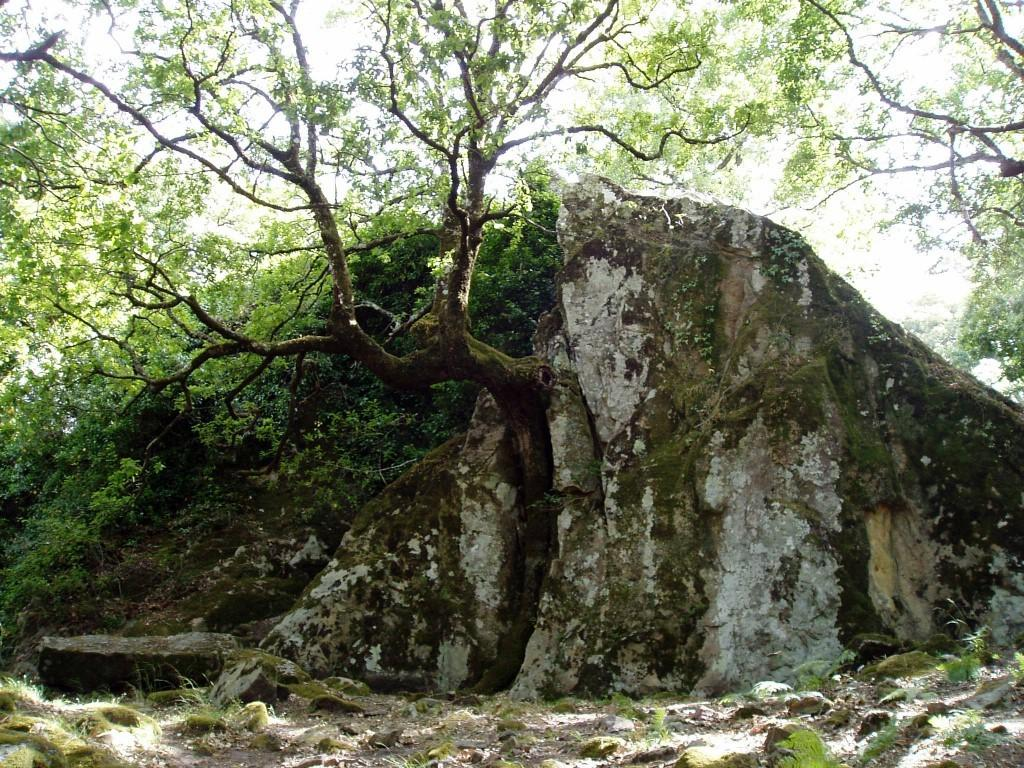What is the main subject in the center of the image? There is a rock in the center of the image. What type of natural vegetation can be seen in the image? There are trees visible in the image. What can be seen in the background of the image? The sky is visible in the background of the image. What type of vegetable is growing near the rock in the image? There are no vegetables present in the image; it features a rock and trees. What type of calculator can be seen on the rock in the image? There is no calculator present in the image; it features a rock and trees. 